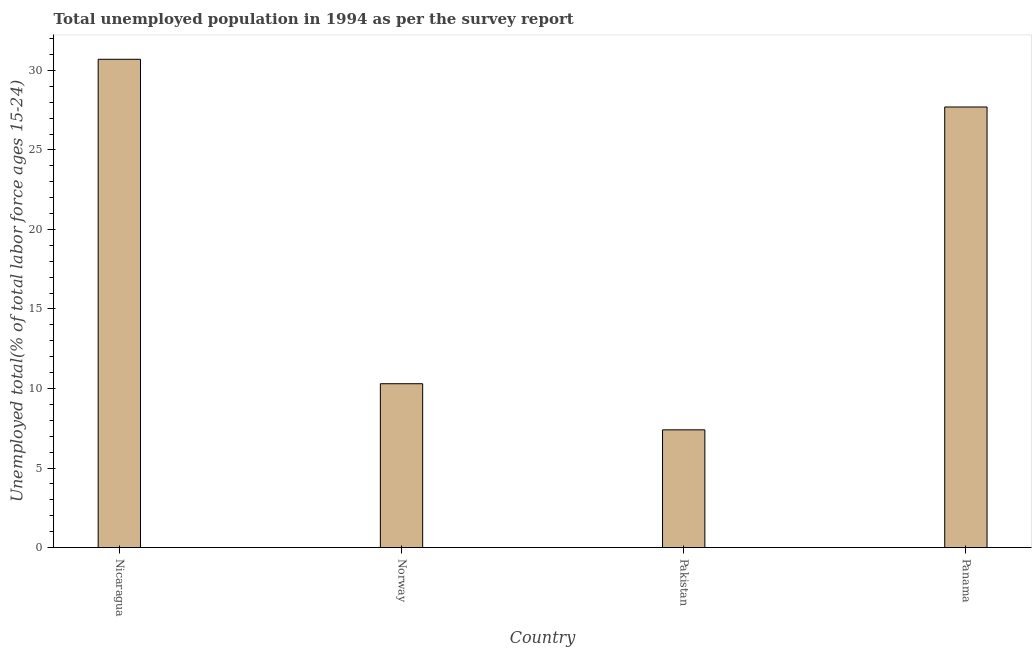Does the graph contain grids?
Provide a succinct answer. No. What is the title of the graph?
Offer a very short reply. Total unemployed population in 1994 as per the survey report. What is the label or title of the Y-axis?
Ensure brevity in your answer.  Unemployed total(% of total labor force ages 15-24). What is the unemployed youth in Nicaragua?
Offer a terse response. 30.7. Across all countries, what is the maximum unemployed youth?
Ensure brevity in your answer.  30.7. Across all countries, what is the minimum unemployed youth?
Provide a succinct answer. 7.4. In which country was the unemployed youth maximum?
Keep it short and to the point. Nicaragua. What is the sum of the unemployed youth?
Provide a short and direct response. 76.1. What is the difference between the unemployed youth in Pakistan and Panama?
Make the answer very short. -20.3. What is the average unemployed youth per country?
Offer a terse response. 19.02. What is the median unemployed youth?
Your answer should be compact. 19. In how many countries, is the unemployed youth greater than 9 %?
Provide a short and direct response. 3. What is the ratio of the unemployed youth in Nicaragua to that in Norway?
Make the answer very short. 2.98. Is the difference between the unemployed youth in Pakistan and Panama greater than the difference between any two countries?
Offer a terse response. No. What is the difference between the highest and the second highest unemployed youth?
Offer a very short reply. 3. Is the sum of the unemployed youth in Norway and Panama greater than the maximum unemployed youth across all countries?
Provide a succinct answer. Yes. What is the difference between the highest and the lowest unemployed youth?
Provide a succinct answer. 23.3. In how many countries, is the unemployed youth greater than the average unemployed youth taken over all countries?
Make the answer very short. 2. How many bars are there?
Make the answer very short. 4. Are all the bars in the graph horizontal?
Your response must be concise. No. Are the values on the major ticks of Y-axis written in scientific E-notation?
Give a very brief answer. No. What is the Unemployed total(% of total labor force ages 15-24) of Nicaragua?
Keep it short and to the point. 30.7. What is the Unemployed total(% of total labor force ages 15-24) of Norway?
Ensure brevity in your answer.  10.3. What is the Unemployed total(% of total labor force ages 15-24) of Pakistan?
Offer a very short reply. 7.4. What is the Unemployed total(% of total labor force ages 15-24) of Panama?
Provide a short and direct response. 27.7. What is the difference between the Unemployed total(% of total labor force ages 15-24) in Nicaragua and Norway?
Provide a short and direct response. 20.4. What is the difference between the Unemployed total(% of total labor force ages 15-24) in Nicaragua and Pakistan?
Your answer should be very brief. 23.3. What is the difference between the Unemployed total(% of total labor force ages 15-24) in Norway and Panama?
Make the answer very short. -17.4. What is the difference between the Unemployed total(% of total labor force ages 15-24) in Pakistan and Panama?
Provide a succinct answer. -20.3. What is the ratio of the Unemployed total(% of total labor force ages 15-24) in Nicaragua to that in Norway?
Make the answer very short. 2.98. What is the ratio of the Unemployed total(% of total labor force ages 15-24) in Nicaragua to that in Pakistan?
Ensure brevity in your answer.  4.15. What is the ratio of the Unemployed total(% of total labor force ages 15-24) in Nicaragua to that in Panama?
Provide a short and direct response. 1.11. What is the ratio of the Unemployed total(% of total labor force ages 15-24) in Norway to that in Pakistan?
Give a very brief answer. 1.39. What is the ratio of the Unemployed total(% of total labor force ages 15-24) in Norway to that in Panama?
Ensure brevity in your answer.  0.37. What is the ratio of the Unemployed total(% of total labor force ages 15-24) in Pakistan to that in Panama?
Your response must be concise. 0.27. 